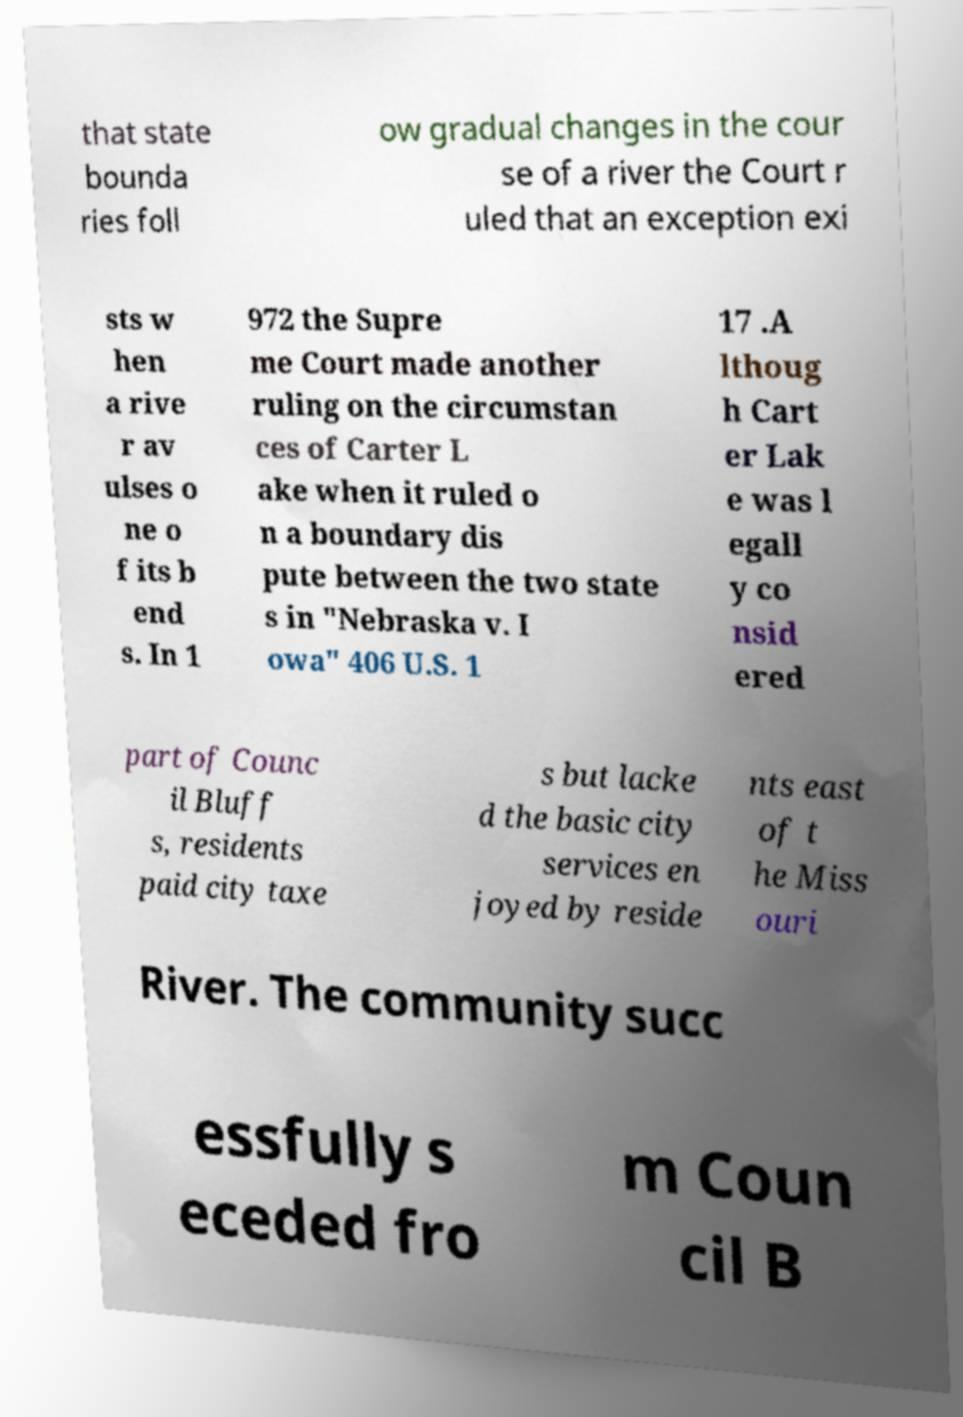Can you accurately transcribe the text from the provided image for me? that state bounda ries foll ow gradual changes in the cour se of a river the Court r uled that an exception exi sts w hen a rive r av ulses o ne o f its b end s. In 1 972 the Supre me Court made another ruling on the circumstan ces of Carter L ake when it ruled o n a boundary dis pute between the two state s in "Nebraska v. I owa" 406 U.S. 1 17 .A lthoug h Cart er Lak e was l egall y co nsid ered part of Counc il Bluff s, residents paid city taxe s but lacke d the basic city services en joyed by reside nts east of t he Miss ouri River. The community succ essfully s eceded fro m Coun cil B 